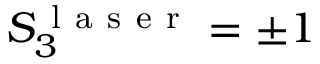<formula> <loc_0><loc_0><loc_500><loc_500>S _ { 3 } ^ { l a s e r } = \pm 1</formula> 